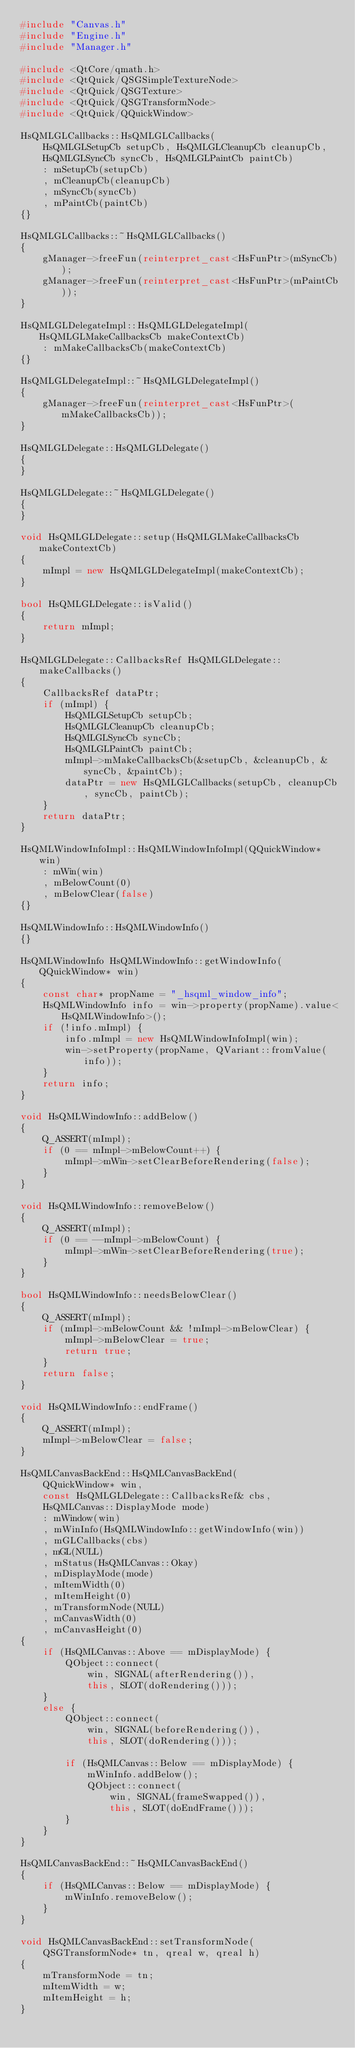Convert code to text. <code><loc_0><loc_0><loc_500><loc_500><_C++_>#include "Canvas.h"
#include "Engine.h"
#include "Manager.h"

#include <QtCore/qmath.h>
#include <QtQuick/QSGSimpleTextureNode>
#include <QtQuick/QSGTexture>
#include <QtQuick/QSGTransformNode>
#include <QtQuick/QQuickWindow>

HsQMLGLCallbacks::HsQMLGLCallbacks(
    HsQMLGLSetupCb setupCb, HsQMLGLCleanupCb cleanupCb,
    HsQMLGLSyncCb syncCb, HsQMLGLPaintCb paintCb)
    : mSetupCb(setupCb)
    , mCleanupCb(cleanupCb)
    , mSyncCb(syncCb)
    , mPaintCb(paintCb)
{}

HsQMLGLCallbacks::~HsQMLGLCallbacks()
{
    gManager->freeFun(reinterpret_cast<HsFunPtr>(mSyncCb));
    gManager->freeFun(reinterpret_cast<HsFunPtr>(mPaintCb));
}

HsQMLGLDelegateImpl::HsQMLGLDelegateImpl(HsQMLGLMakeCallbacksCb makeContextCb)
    : mMakeCallbacksCb(makeContextCb)
{}

HsQMLGLDelegateImpl::~HsQMLGLDelegateImpl()
{
    gManager->freeFun(reinterpret_cast<HsFunPtr>(mMakeCallbacksCb));
}

HsQMLGLDelegate::HsQMLGLDelegate()
{
}

HsQMLGLDelegate::~HsQMLGLDelegate()
{
}

void HsQMLGLDelegate::setup(HsQMLGLMakeCallbacksCb makeContextCb)
{
    mImpl = new HsQMLGLDelegateImpl(makeContextCb);
}

bool HsQMLGLDelegate::isValid()
{
    return mImpl;
}

HsQMLGLDelegate::CallbacksRef HsQMLGLDelegate::makeCallbacks()
{
    CallbacksRef dataPtr;
    if (mImpl) {
        HsQMLGLSetupCb setupCb;
        HsQMLGLCleanupCb cleanupCb;
        HsQMLGLSyncCb syncCb;
        HsQMLGLPaintCb paintCb;
        mImpl->mMakeCallbacksCb(&setupCb, &cleanupCb, &syncCb, &paintCb);
        dataPtr = new HsQMLGLCallbacks(setupCb, cleanupCb, syncCb, paintCb);
    }
    return dataPtr;
}

HsQMLWindowInfoImpl::HsQMLWindowInfoImpl(QQuickWindow* win)
    : mWin(win)
    , mBelowCount(0)
    , mBelowClear(false)
{}

HsQMLWindowInfo::HsQMLWindowInfo()
{}

HsQMLWindowInfo HsQMLWindowInfo::getWindowInfo(QQuickWindow* win)
{
    const char* propName = "_hsqml_window_info";
    HsQMLWindowInfo info = win->property(propName).value<HsQMLWindowInfo>();
    if (!info.mImpl) {
        info.mImpl = new HsQMLWindowInfoImpl(win);
        win->setProperty(propName, QVariant::fromValue(info));
    }
    return info;
}

void HsQMLWindowInfo::addBelow()
{
    Q_ASSERT(mImpl);
    if (0 == mImpl->mBelowCount++) {
        mImpl->mWin->setClearBeforeRendering(false);
    }
}

void HsQMLWindowInfo::removeBelow()
{
    Q_ASSERT(mImpl);
    if (0 == --mImpl->mBelowCount) {
        mImpl->mWin->setClearBeforeRendering(true);
    }
}

bool HsQMLWindowInfo::needsBelowClear()
{
    Q_ASSERT(mImpl);
    if (mImpl->mBelowCount && !mImpl->mBelowClear) {
        mImpl->mBelowClear = true;
        return true;
    }
    return false;
}

void HsQMLWindowInfo::endFrame()
{
    Q_ASSERT(mImpl);
    mImpl->mBelowClear = false;
}

HsQMLCanvasBackEnd::HsQMLCanvasBackEnd(
    QQuickWindow* win,
    const HsQMLGLDelegate::CallbacksRef& cbs,
    HsQMLCanvas::DisplayMode mode)
    : mWindow(win)
    , mWinInfo(HsQMLWindowInfo::getWindowInfo(win))
    , mGLCallbacks(cbs)
    , mGL(NULL)
    , mStatus(HsQMLCanvas::Okay)
    , mDisplayMode(mode)
    , mItemWidth(0)
    , mItemHeight(0)
    , mTransformNode(NULL)
    , mCanvasWidth(0)
    , mCanvasHeight(0)
{
    if (HsQMLCanvas::Above == mDisplayMode) {
        QObject::connect(
            win, SIGNAL(afterRendering()),
            this, SLOT(doRendering()));
    }
    else {
        QObject::connect(
            win, SIGNAL(beforeRendering()),
            this, SLOT(doRendering()));

        if (HsQMLCanvas::Below == mDisplayMode) {
            mWinInfo.addBelow();
            QObject::connect(
                win, SIGNAL(frameSwapped()),
                this, SLOT(doEndFrame()));
        }
    }
}

HsQMLCanvasBackEnd::~HsQMLCanvasBackEnd()
{
    if (HsQMLCanvas::Below == mDisplayMode) {
        mWinInfo.removeBelow();
    }
}

void HsQMLCanvasBackEnd::setTransformNode(
    QSGTransformNode* tn, qreal w, qreal h)
{
    mTransformNode = tn;
    mItemWidth = w;
    mItemHeight = h;
}
</code> 